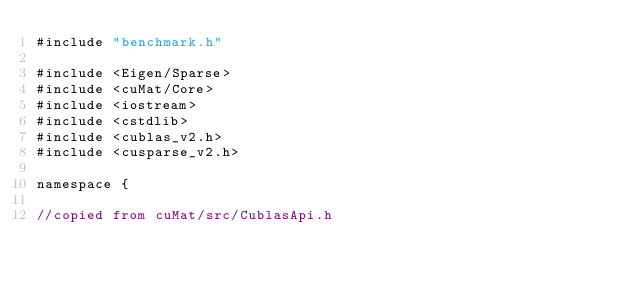Convert code to text. <code><loc_0><loc_0><loc_500><loc_500><_Cuda_>#include "benchmark.h"

#include <Eigen/Sparse>
#include <cuMat/Core>
#include <iostream>
#include <cstdlib>
#include <cublas_v2.h>
#include <cusparse_v2.h>

namespace {

//copied from cuMat/src/CublasApi.h
</code> 